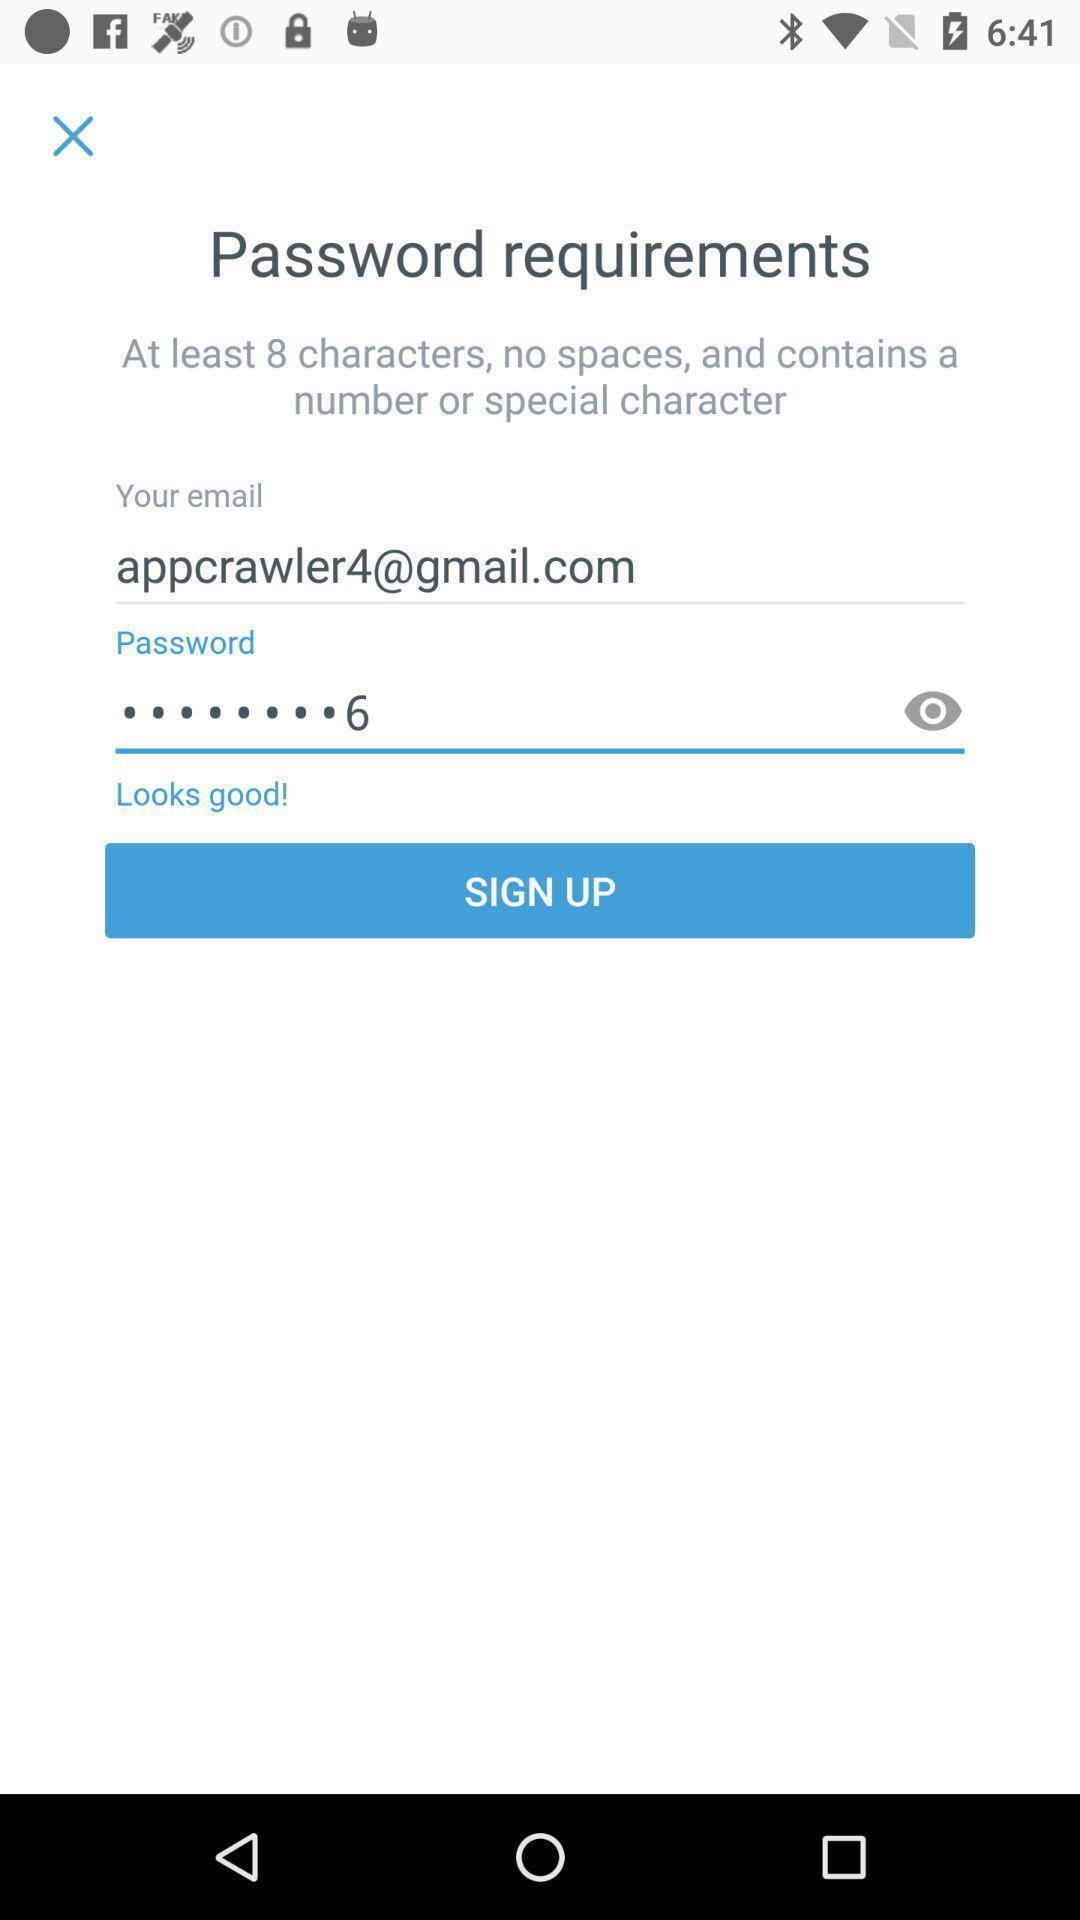Describe this image in words. Sign up page. 